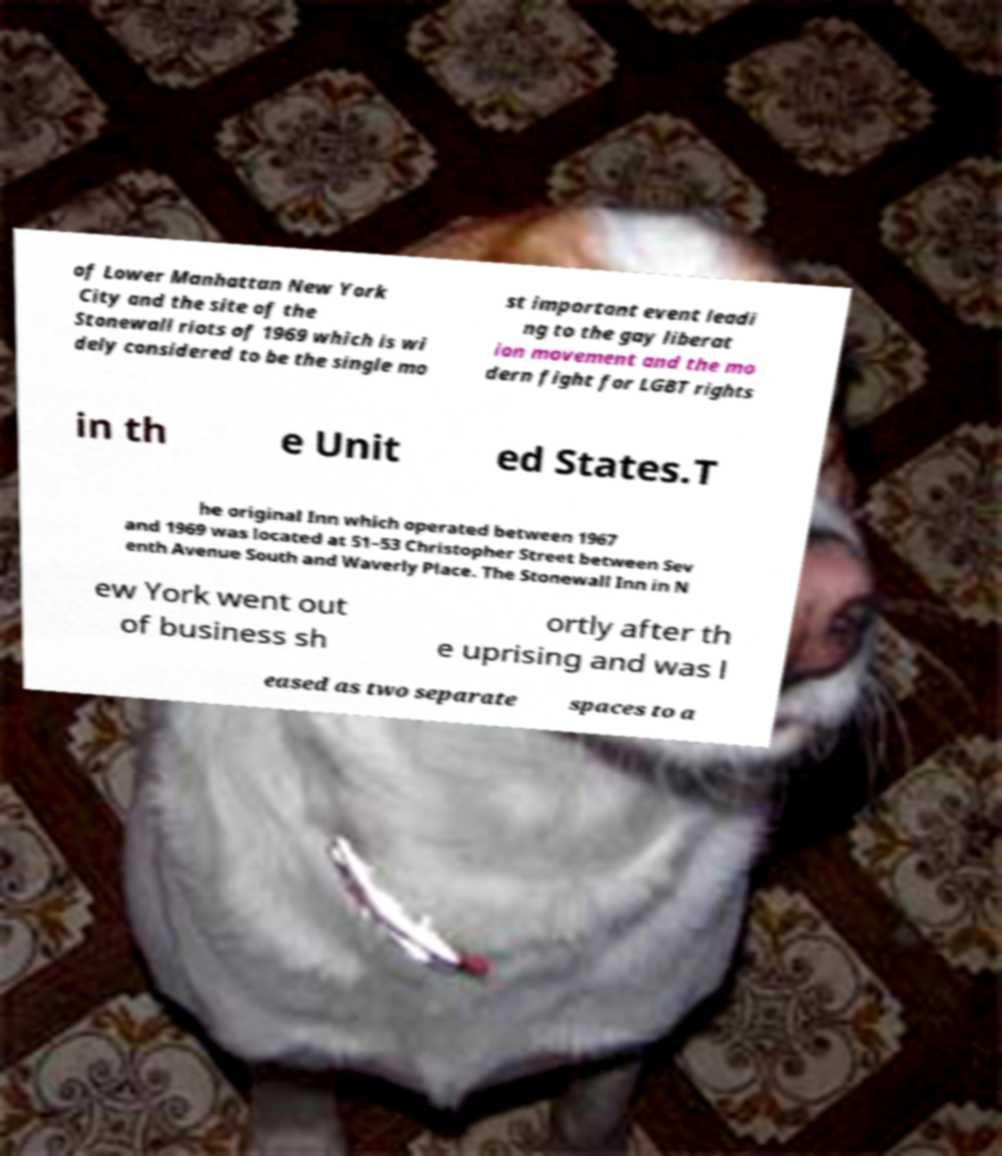I need the written content from this picture converted into text. Can you do that? of Lower Manhattan New York City and the site of the Stonewall riots of 1969 which is wi dely considered to be the single mo st important event leadi ng to the gay liberat ion movement and the mo dern fight for LGBT rights in th e Unit ed States.T he original Inn which operated between 1967 and 1969 was located at 51–53 Christopher Street between Sev enth Avenue South and Waverly Place. The Stonewall Inn in N ew York went out of business sh ortly after th e uprising and was l eased as two separate spaces to a 